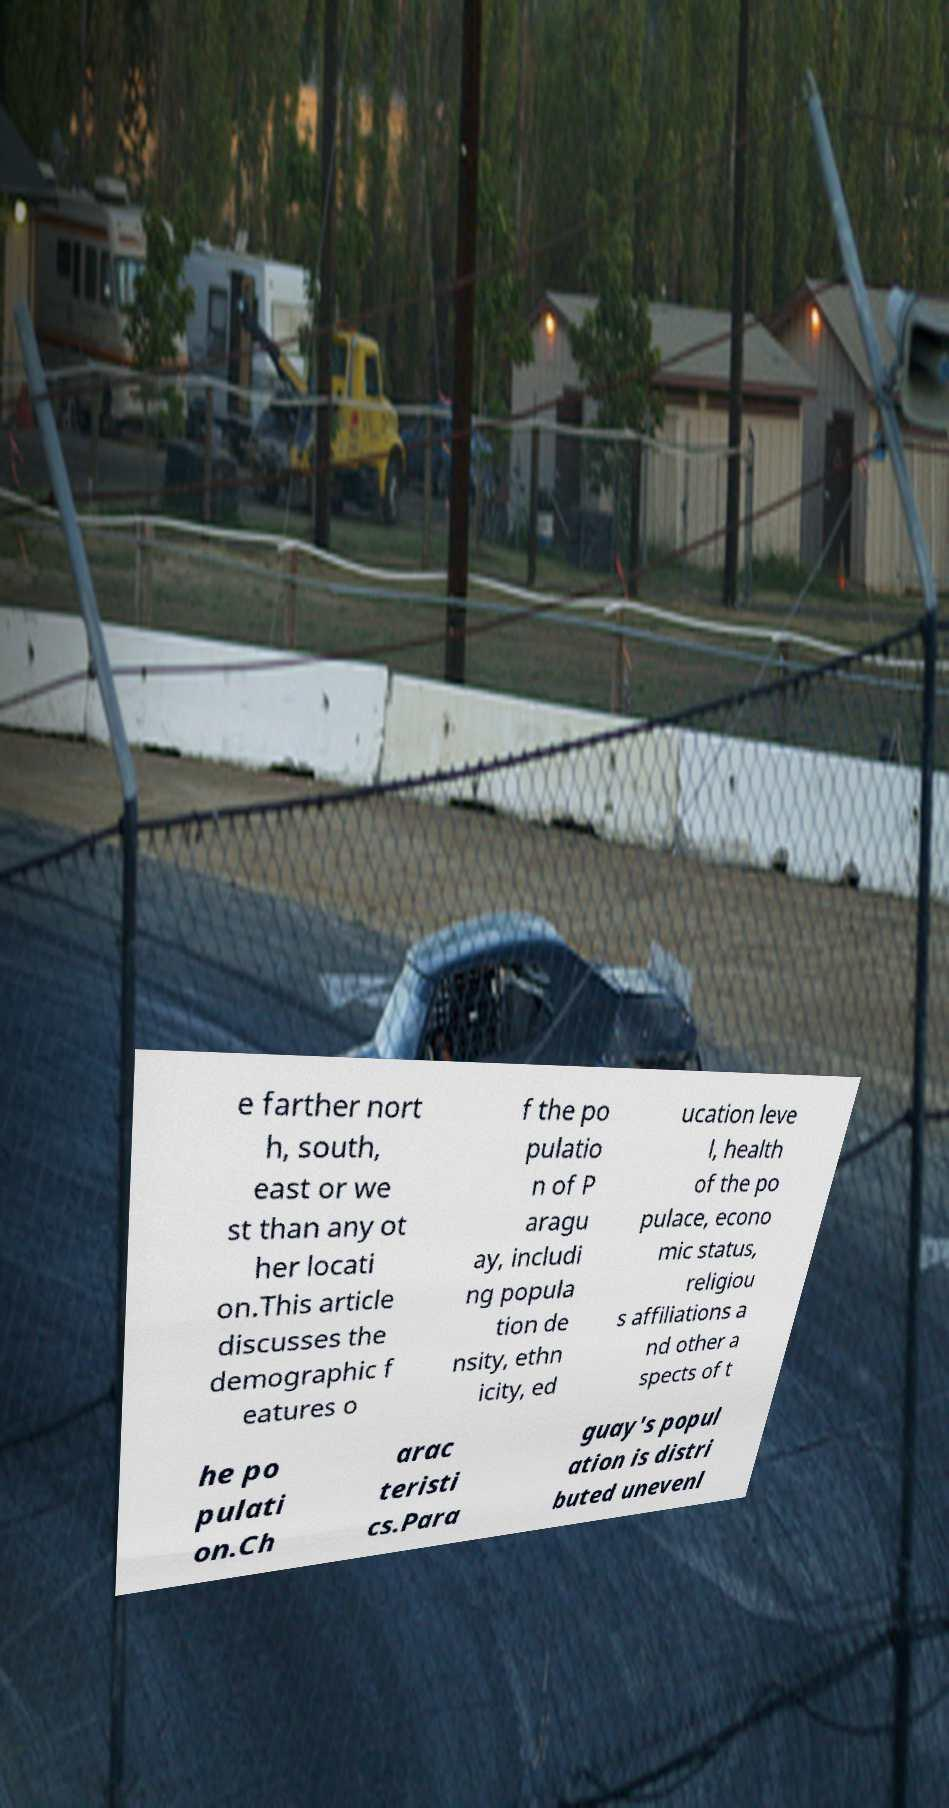Please identify and transcribe the text found in this image. e farther nort h, south, east or we st than any ot her locati on.This article discusses the demographic f eatures o f the po pulatio n of P aragu ay, includi ng popula tion de nsity, ethn icity, ed ucation leve l, health of the po pulace, econo mic status, religiou s affiliations a nd other a spects of t he po pulati on.Ch arac teristi cs.Para guay's popul ation is distri buted unevenl 